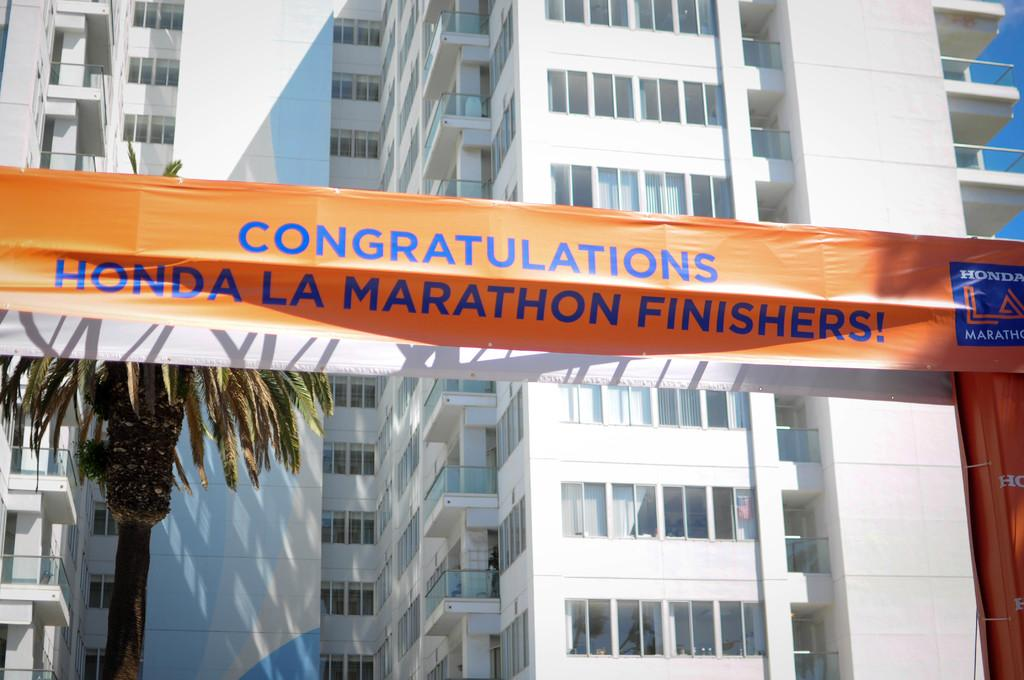What is the main feature in the middle of the image? There is an orange color banner in the middle of the image. What is written on the banner? There is text on the banner. What can be seen on the left side of the image? There is a tree on the left side of the image. What is visible in the background of the image? There are buildings in the background of the image. How many rabbits are hopping around the tree in the image? There are no rabbits present in the image; it features a tree and an orange color banner with text. 